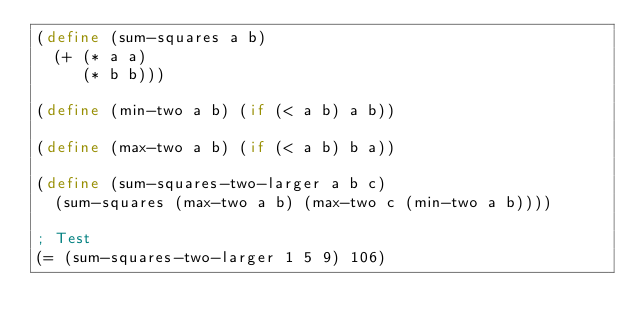<code> <loc_0><loc_0><loc_500><loc_500><_Scheme_>(define (sum-squares a b)
  (+ (* a a)
     (* b b)))

(define (min-two a b) (if (< a b) a b))

(define (max-two a b) (if (< a b) b a))

(define (sum-squares-two-larger a b c)
  (sum-squares (max-two a b) (max-two c (min-two a b))))

; Test
(= (sum-squares-two-larger 1 5 9) 106)
</code> 